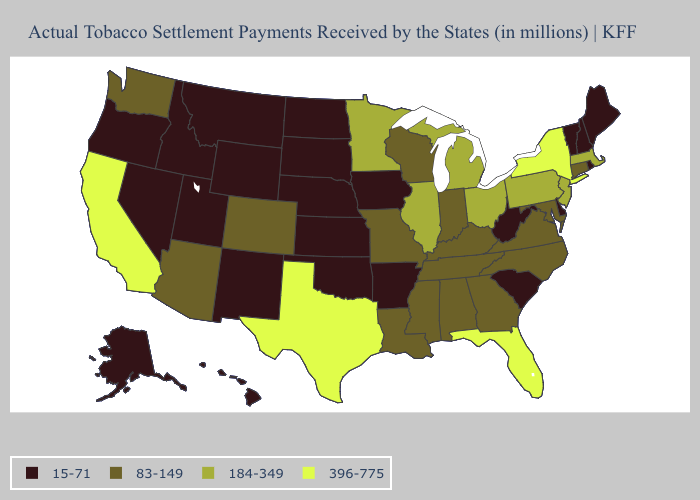Among the states that border South Carolina , which have the highest value?
Answer briefly. Georgia, North Carolina. Does Oklahoma have the highest value in the USA?
Answer briefly. No. Name the states that have a value in the range 15-71?
Give a very brief answer. Alaska, Arkansas, Delaware, Hawaii, Idaho, Iowa, Kansas, Maine, Montana, Nebraska, Nevada, New Hampshire, New Mexico, North Dakota, Oklahoma, Oregon, Rhode Island, South Carolina, South Dakota, Utah, Vermont, West Virginia, Wyoming. Which states hav the highest value in the MidWest?
Quick response, please. Illinois, Michigan, Minnesota, Ohio. What is the highest value in the USA?
Answer briefly. 396-775. What is the value of South Dakota?
Quick response, please. 15-71. What is the value of California?
Keep it brief. 396-775. What is the highest value in the USA?
Be succinct. 396-775. Name the states that have a value in the range 83-149?
Keep it brief. Alabama, Arizona, Colorado, Connecticut, Georgia, Indiana, Kentucky, Louisiana, Maryland, Mississippi, Missouri, North Carolina, Tennessee, Virginia, Washington, Wisconsin. Which states have the lowest value in the South?
Write a very short answer. Arkansas, Delaware, Oklahoma, South Carolina, West Virginia. Among the states that border Vermont , which have the lowest value?
Short answer required. New Hampshire. What is the value of Illinois?
Give a very brief answer. 184-349. What is the value of South Carolina?
Keep it brief. 15-71. What is the lowest value in the USA?
Short answer required. 15-71. 